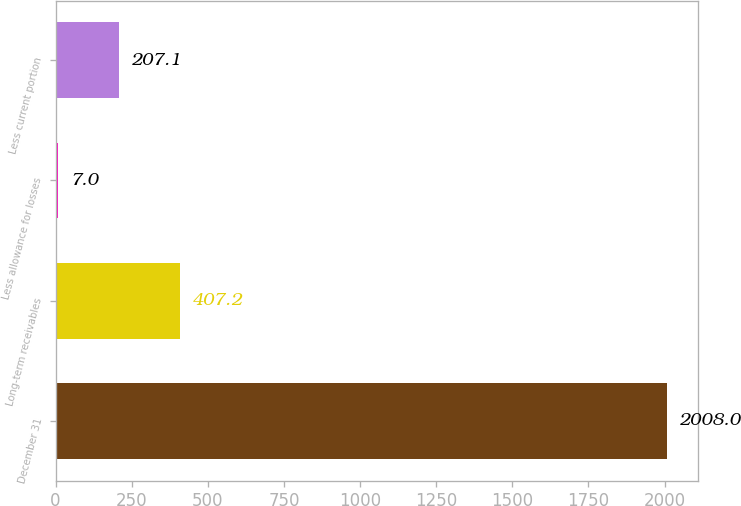Convert chart. <chart><loc_0><loc_0><loc_500><loc_500><bar_chart><fcel>December 31<fcel>Long-term receivables<fcel>Less allowance for losses<fcel>Less current portion<nl><fcel>2008<fcel>407.2<fcel>7<fcel>207.1<nl></chart> 